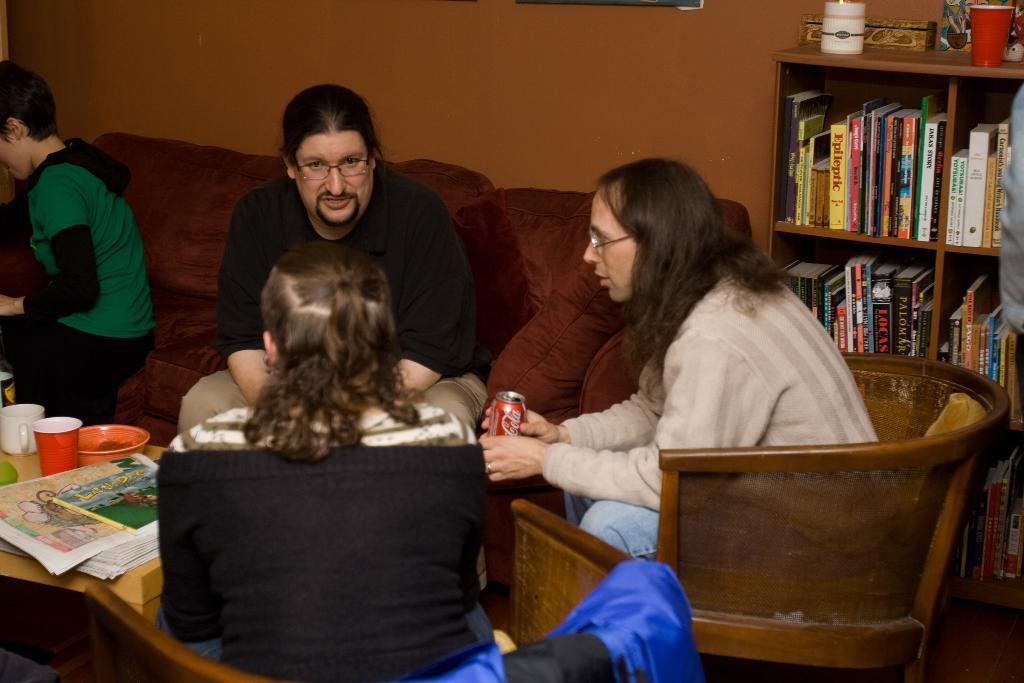Could you give a brief overview of what you see in this image? In this picture I can see 4 persons in front who are sitting on chairs and sofa and I can see a table near to them, on which I can see 2 cups and papers. On the right side of this picture I can see the shelves on which there are number of books, a cup and other things. In the background I can see the wall. I can also see that, the person on the right is holding a can and I see something is written on it. 